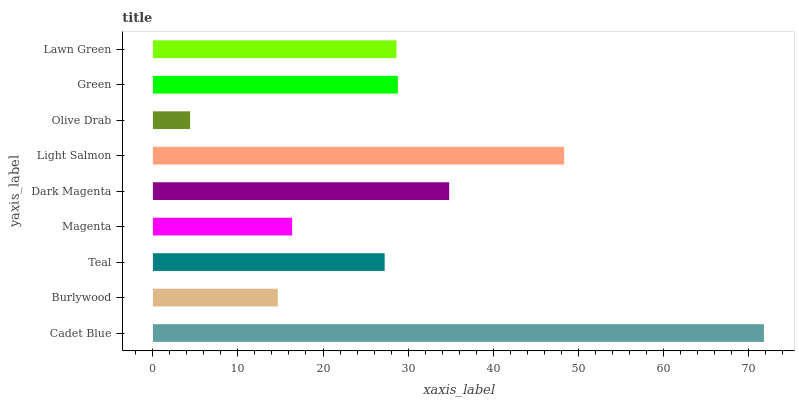Is Olive Drab the minimum?
Answer yes or no. Yes. Is Cadet Blue the maximum?
Answer yes or no. Yes. Is Burlywood the minimum?
Answer yes or no. No. Is Burlywood the maximum?
Answer yes or no. No. Is Cadet Blue greater than Burlywood?
Answer yes or no. Yes. Is Burlywood less than Cadet Blue?
Answer yes or no. Yes. Is Burlywood greater than Cadet Blue?
Answer yes or no. No. Is Cadet Blue less than Burlywood?
Answer yes or no. No. Is Lawn Green the high median?
Answer yes or no. Yes. Is Lawn Green the low median?
Answer yes or no. Yes. Is Magenta the high median?
Answer yes or no. No. Is Burlywood the low median?
Answer yes or no. No. 